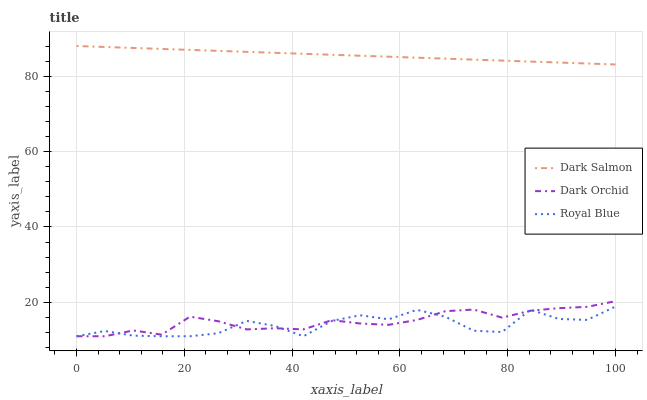Does Royal Blue have the minimum area under the curve?
Answer yes or no. Yes. Does Dark Salmon have the maximum area under the curve?
Answer yes or no. Yes. Does Dark Orchid have the minimum area under the curve?
Answer yes or no. No. Does Dark Orchid have the maximum area under the curve?
Answer yes or no. No. Is Dark Salmon the smoothest?
Answer yes or no. Yes. Is Royal Blue the roughest?
Answer yes or no. Yes. Is Dark Orchid the smoothest?
Answer yes or no. No. Is Dark Orchid the roughest?
Answer yes or no. No. Does Royal Blue have the lowest value?
Answer yes or no. Yes. Does Dark Salmon have the lowest value?
Answer yes or no. No. Does Dark Salmon have the highest value?
Answer yes or no. Yes. Does Dark Orchid have the highest value?
Answer yes or no. No. Is Royal Blue less than Dark Salmon?
Answer yes or no. Yes. Is Dark Salmon greater than Royal Blue?
Answer yes or no. Yes. Does Dark Orchid intersect Royal Blue?
Answer yes or no. Yes. Is Dark Orchid less than Royal Blue?
Answer yes or no. No. Is Dark Orchid greater than Royal Blue?
Answer yes or no. No. Does Royal Blue intersect Dark Salmon?
Answer yes or no. No. 